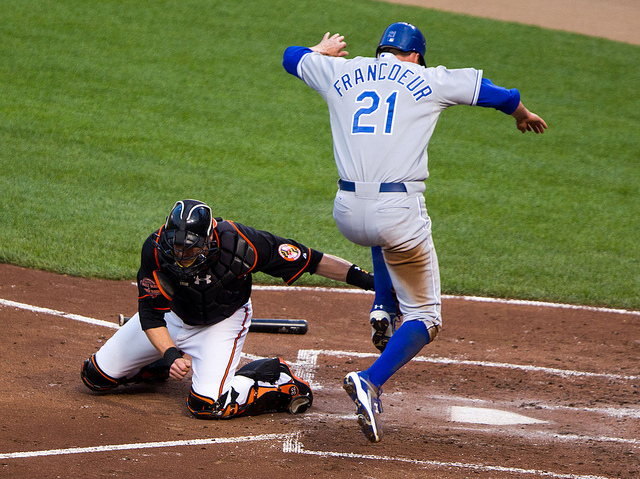Identify the text displayed in this image. FRANCOEUR 21 